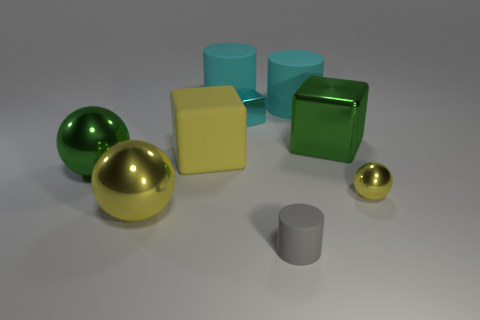Is there a cyan cube of the same size as the green shiny cube?
Give a very brief answer. No. Is the number of large matte cubes greater than the number of cyan things?
Your answer should be compact. No. Does the green thing that is right of the big green ball have the same size as the yellow sphere left of the green cube?
Provide a succinct answer. Yes. How many rubber cylinders are on the right side of the small cyan metal object and behind the tiny cyan thing?
Provide a succinct answer. 1. There is a tiny metal object that is the same shape as the large yellow shiny thing; what is its color?
Your response must be concise. Yellow. Is the number of tiny cyan cubes less than the number of big red spheres?
Offer a terse response. No. There is a gray matte cylinder; is it the same size as the shiny thing that is left of the big yellow shiny object?
Provide a succinct answer. No. There is a tiny shiny object that is behind the big green metal object that is to the right of the large yellow shiny sphere; what color is it?
Make the answer very short. Cyan. How many things are either large balls behind the tiny sphere or tiny objects on the right side of the tiny cylinder?
Offer a very short reply. 2. Does the green cube have the same size as the green ball?
Make the answer very short. Yes. 